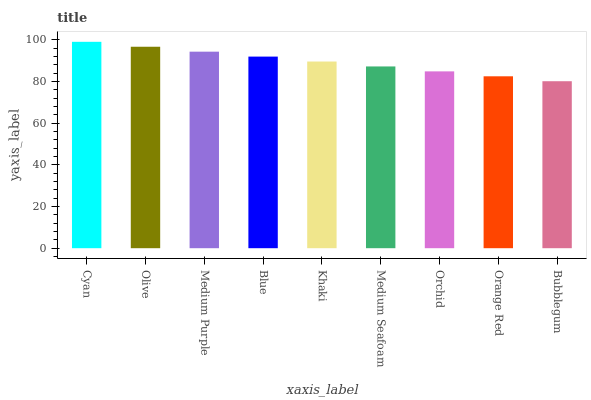Is Bubblegum the minimum?
Answer yes or no. Yes. Is Cyan the maximum?
Answer yes or no. Yes. Is Olive the minimum?
Answer yes or no. No. Is Olive the maximum?
Answer yes or no. No. Is Cyan greater than Olive?
Answer yes or no. Yes. Is Olive less than Cyan?
Answer yes or no. Yes. Is Olive greater than Cyan?
Answer yes or no. No. Is Cyan less than Olive?
Answer yes or no. No. Is Khaki the high median?
Answer yes or no. Yes. Is Khaki the low median?
Answer yes or no. Yes. Is Orange Red the high median?
Answer yes or no. No. Is Blue the low median?
Answer yes or no. No. 